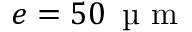<formula> <loc_0><loc_0><loc_500><loc_500>e = 5 0 \, \text  mu m</formula> 